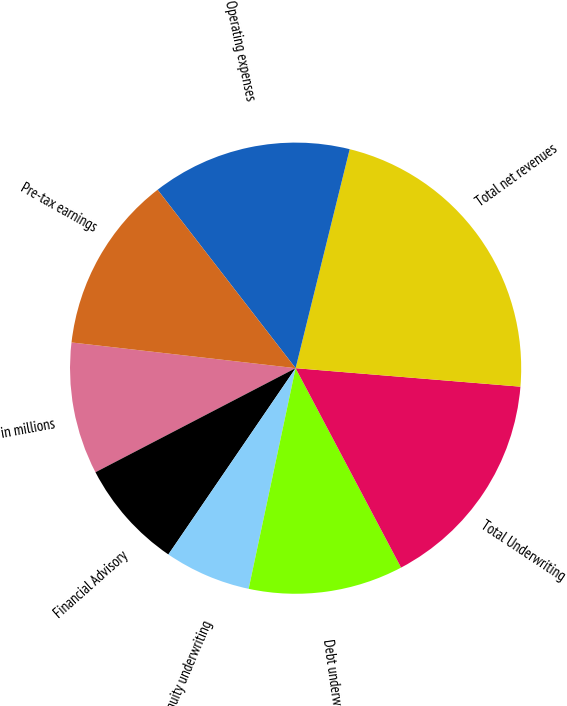Convert chart to OTSL. <chart><loc_0><loc_0><loc_500><loc_500><pie_chart><fcel>in millions<fcel>Financial Advisory<fcel>Equity underwriting<fcel>Debt underwriting<fcel>Total Underwriting<fcel>Total net revenues<fcel>Operating expenses<fcel>Pre-tax earnings<nl><fcel>9.45%<fcel>7.83%<fcel>6.2%<fcel>11.08%<fcel>15.95%<fcel>22.45%<fcel>14.33%<fcel>12.7%<nl></chart> 